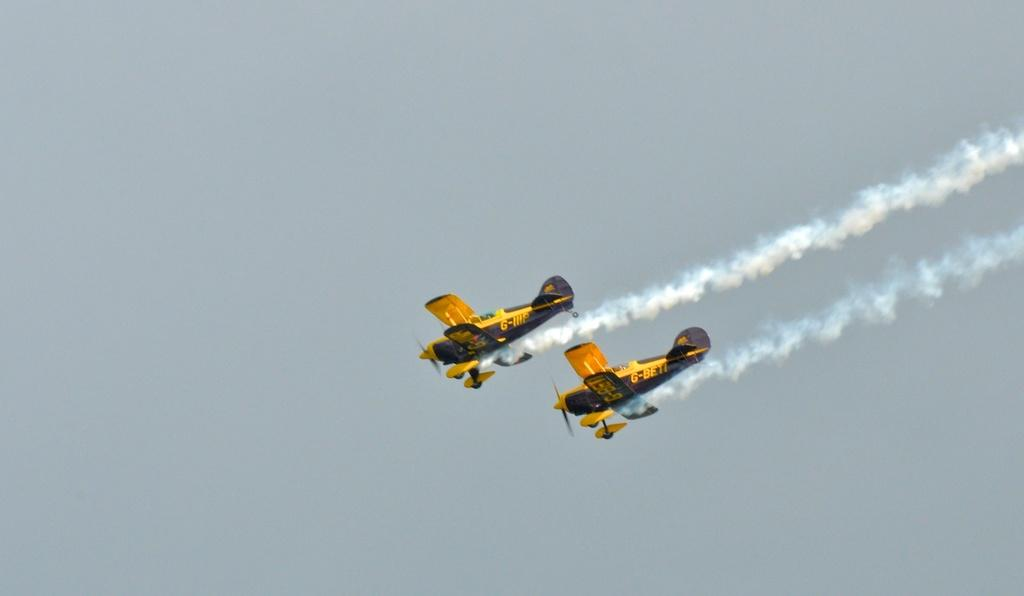What can be seen on the right side of the image? There are two aircraft on the right side of the image. What are the aircraft doing in the image? The aircraft are flying in the air and emitting smoke. What is visible in the background of the image? There are clouds in the background of the image. What color is the sky in the image? The sky is blue in the image. What type of pain can be seen on the aircraft's faces in the image? There are no faces on the aircraft, so it is not possible to determine if they are experiencing any pain. 